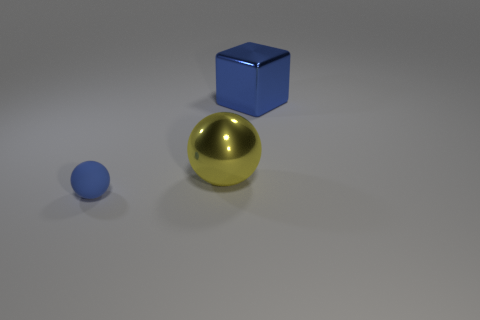Can you describe the lighting in the scene? The lighting in the scene seems to be soft and diffused, with a single prominent light source illuminating the objects from above. Shadows are gently cast below and to the right of the objects, indicating the light may be coming from the upper left side of the image frame. 